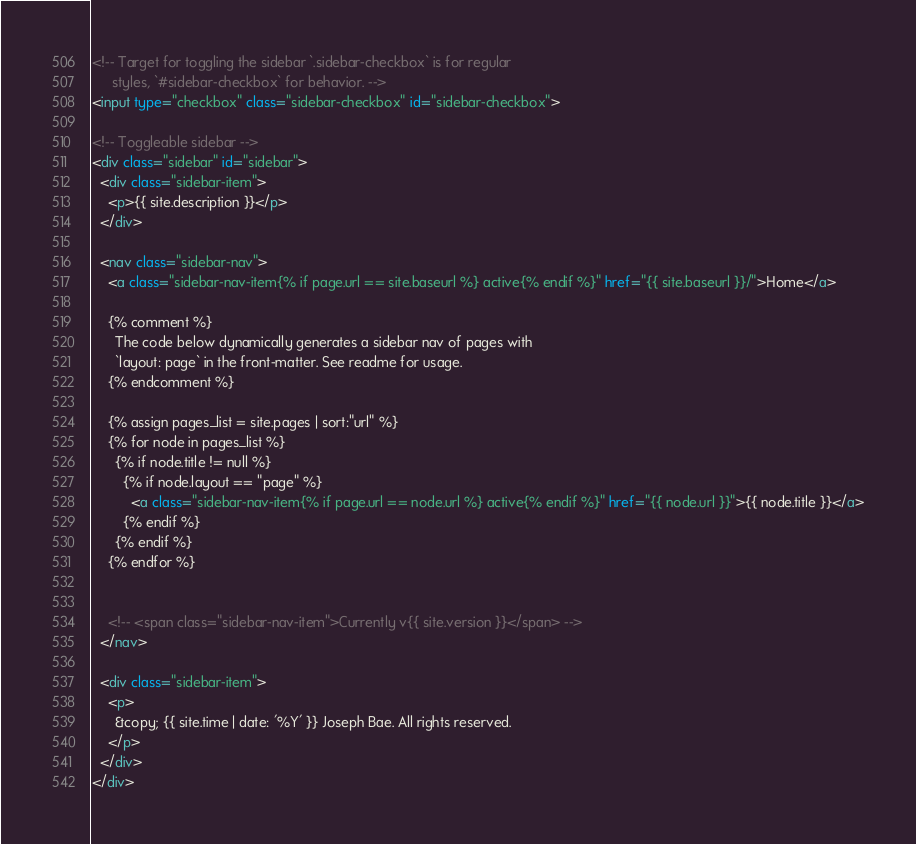Convert code to text. <code><loc_0><loc_0><loc_500><loc_500><_HTML_><!-- Target for toggling the sidebar `.sidebar-checkbox` is for regular
     styles, `#sidebar-checkbox` for behavior. -->
<input type="checkbox" class="sidebar-checkbox" id="sidebar-checkbox">

<!-- Toggleable sidebar -->
<div class="sidebar" id="sidebar">
  <div class="sidebar-item">
    <p>{{ site.description }}</p>
  </div>

  <nav class="sidebar-nav">
    <a class="sidebar-nav-item{% if page.url == site.baseurl %} active{% endif %}" href="{{ site.baseurl }}/">Home</a>

    {% comment %}
      The code below dynamically generates a sidebar nav of pages with
      `layout: page` in the front-matter. See readme for usage.
    {% endcomment %}

    {% assign pages_list = site.pages | sort:"url" %}
    {% for node in pages_list %}
      {% if node.title != null %}
        {% if node.layout == "page" %}
          <a class="sidebar-nav-item{% if page.url == node.url %} active{% endif %}" href="{{ node.url }}">{{ node.title }}</a>
        {% endif %}
      {% endif %}
    {% endfor %}

    
    <!-- <span class="sidebar-nav-item">Currently v{{ site.version }}</span> -->
  </nav>

  <div class="sidebar-item">
    <p>
      &copy; {{ site.time | date: '%Y' }} Joseph Bae. All rights reserved.
    </p>
  </div>
</div>
</code> 